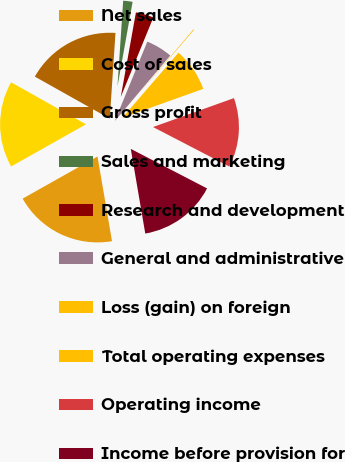<chart> <loc_0><loc_0><loc_500><loc_500><pie_chart><fcel>Net sales<fcel>Cost of sales<fcel>Gross profit<fcel>Sales and marketing<fcel>Research and development<fcel>General and administrative<fcel>Loss (gain) on foreign<fcel>Total operating expenses<fcel>Operating income<fcel>Income before provision for<nl><fcel>19.54%<fcel>16.3%<fcel>17.92%<fcel>1.76%<fcel>3.37%<fcel>4.99%<fcel>0.14%<fcel>8.22%<fcel>13.07%<fcel>14.69%<nl></chart> 